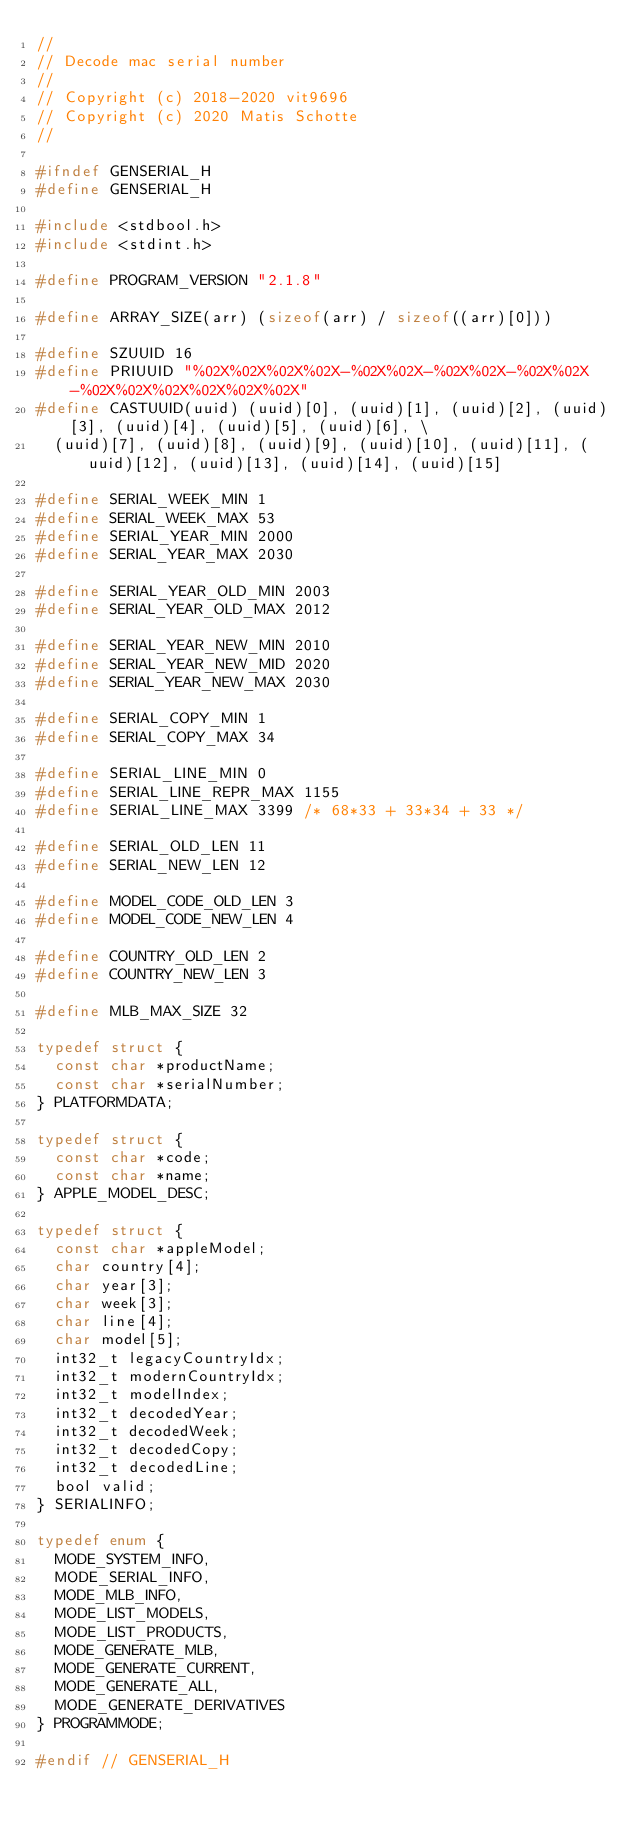<code> <loc_0><loc_0><loc_500><loc_500><_C_>//
// Decode mac serial number
//
// Copyright (c) 2018-2020 vit9696
// Copyright (c) 2020 Matis Schotte
//

#ifndef GENSERIAL_H
#define GENSERIAL_H

#include <stdbool.h>
#include <stdint.h>

#define PROGRAM_VERSION "2.1.8"

#define ARRAY_SIZE(arr) (sizeof(arr) / sizeof((arr)[0]))

#define SZUUID 16
#define PRIUUID "%02X%02X%02X%02X-%02X%02X-%02X%02X-%02X%02X-%02X%02X%02X%02X%02X%02X"
#define CASTUUID(uuid) (uuid)[0], (uuid)[1], (uuid)[2], (uuid)[3], (uuid)[4], (uuid)[5], (uuid)[6], \
  (uuid)[7], (uuid)[8], (uuid)[9], (uuid)[10], (uuid)[11], (uuid)[12], (uuid)[13], (uuid)[14], (uuid)[15]

#define SERIAL_WEEK_MIN 1
#define SERIAL_WEEK_MAX 53
#define SERIAL_YEAR_MIN 2000
#define SERIAL_YEAR_MAX 2030

#define SERIAL_YEAR_OLD_MIN 2003
#define SERIAL_YEAR_OLD_MAX 2012

#define SERIAL_YEAR_NEW_MIN 2010
#define SERIAL_YEAR_NEW_MID 2020
#define SERIAL_YEAR_NEW_MAX 2030

#define SERIAL_COPY_MIN 1
#define SERIAL_COPY_MAX 34

#define SERIAL_LINE_MIN 0
#define SERIAL_LINE_REPR_MAX 1155
#define SERIAL_LINE_MAX 3399 /* 68*33 + 33*34 + 33 */

#define SERIAL_OLD_LEN 11
#define SERIAL_NEW_LEN 12

#define MODEL_CODE_OLD_LEN 3
#define MODEL_CODE_NEW_LEN 4

#define COUNTRY_OLD_LEN 2
#define COUNTRY_NEW_LEN 3

#define MLB_MAX_SIZE 32

typedef struct {
  const char *productName;
  const char *serialNumber;
} PLATFORMDATA;

typedef struct {
  const char *code;
  const char *name;
} APPLE_MODEL_DESC;

typedef struct {
  const char *appleModel;
  char country[4];
  char year[3];
  char week[3];
  char line[4];
  char model[5];
  int32_t legacyCountryIdx;
  int32_t modernCountryIdx;
  int32_t modelIndex;
  int32_t decodedYear;
  int32_t decodedWeek;
  int32_t decodedCopy;
  int32_t decodedLine;
  bool valid;
} SERIALINFO;

typedef enum {
  MODE_SYSTEM_INFO,
  MODE_SERIAL_INFO,
  MODE_MLB_INFO,
  MODE_LIST_MODELS,
  MODE_LIST_PRODUCTS,
  MODE_GENERATE_MLB,
  MODE_GENERATE_CURRENT,
  MODE_GENERATE_ALL,
  MODE_GENERATE_DERIVATIVES
} PROGRAMMODE;

#endif // GENSERIAL_H
</code> 